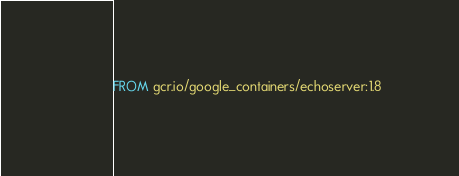<code> <loc_0><loc_0><loc_500><loc_500><_Dockerfile_>FROM gcr.io/google_containers/echoserver:1.8
</code> 